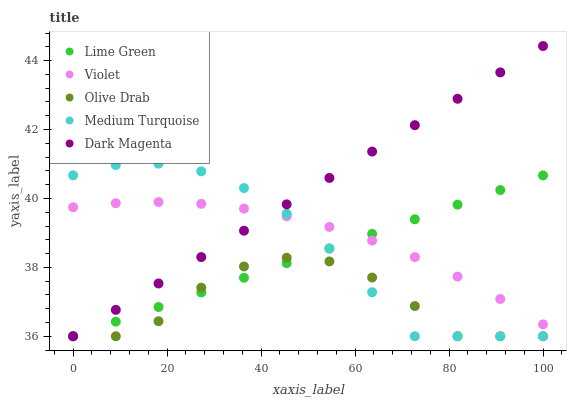Does Olive Drab have the minimum area under the curve?
Answer yes or no. Yes. Does Dark Magenta have the maximum area under the curve?
Answer yes or no. Yes. Does Lime Green have the minimum area under the curve?
Answer yes or no. No. Does Lime Green have the maximum area under the curve?
Answer yes or no. No. Is Dark Magenta the smoothest?
Answer yes or no. Yes. Is Olive Drab the roughest?
Answer yes or no. Yes. Is Lime Green the smoothest?
Answer yes or no. No. Is Lime Green the roughest?
Answer yes or no. No. Does Dark Magenta have the lowest value?
Answer yes or no. Yes. Does Violet have the lowest value?
Answer yes or no. No. Does Dark Magenta have the highest value?
Answer yes or no. Yes. Does Lime Green have the highest value?
Answer yes or no. No. Is Olive Drab less than Violet?
Answer yes or no. Yes. Is Violet greater than Olive Drab?
Answer yes or no. Yes. Does Lime Green intersect Dark Magenta?
Answer yes or no. Yes. Is Lime Green less than Dark Magenta?
Answer yes or no. No. Is Lime Green greater than Dark Magenta?
Answer yes or no. No. Does Olive Drab intersect Violet?
Answer yes or no. No. 